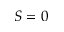<formula> <loc_0><loc_0><loc_500><loc_500>S = 0</formula> 